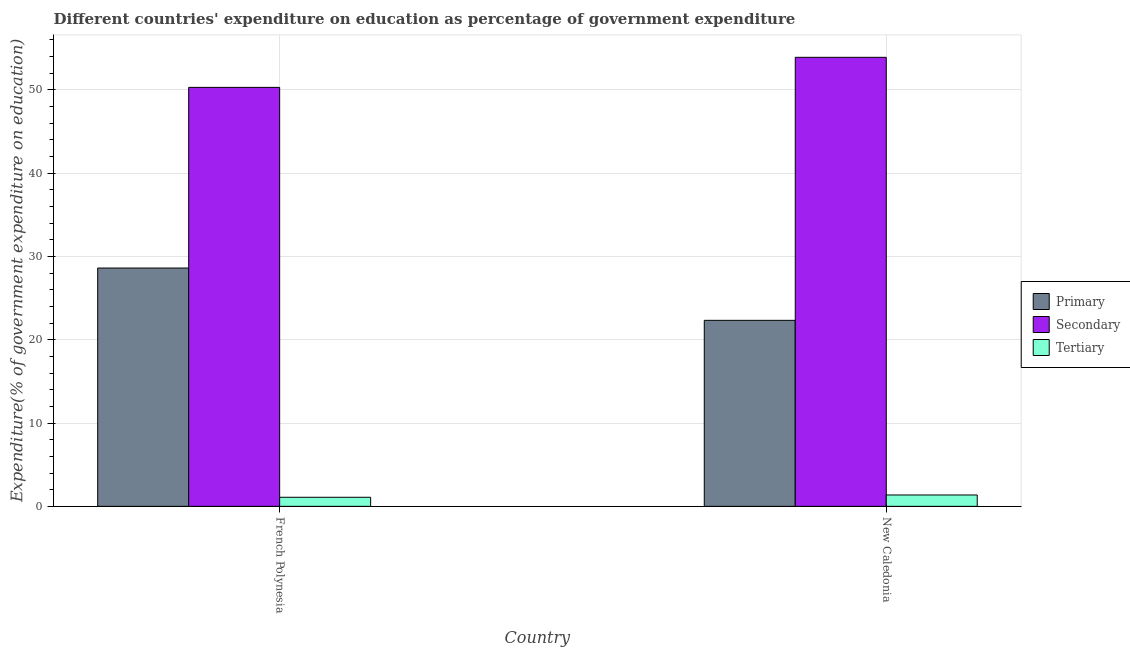How many different coloured bars are there?
Your answer should be very brief. 3. Are the number of bars on each tick of the X-axis equal?
Give a very brief answer. Yes. How many bars are there on the 1st tick from the left?
Your answer should be compact. 3. How many bars are there on the 1st tick from the right?
Your response must be concise. 3. What is the label of the 2nd group of bars from the left?
Provide a short and direct response. New Caledonia. What is the expenditure on tertiary education in French Polynesia?
Offer a terse response. 1.09. Across all countries, what is the maximum expenditure on primary education?
Ensure brevity in your answer.  28.61. Across all countries, what is the minimum expenditure on secondary education?
Give a very brief answer. 50.3. In which country was the expenditure on tertiary education maximum?
Keep it short and to the point. New Caledonia. In which country was the expenditure on secondary education minimum?
Give a very brief answer. French Polynesia. What is the total expenditure on tertiary education in the graph?
Ensure brevity in your answer.  2.45. What is the difference between the expenditure on secondary education in French Polynesia and that in New Caledonia?
Give a very brief answer. -3.61. What is the difference between the expenditure on tertiary education in French Polynesia and the expenditure on secondary education in New Caledonia?
Make the answer very short. -52.82. What is the average expenditure on primary education per country?
Ensure brevity in your answer.  25.47. What is the difference between the expenditure on tertiary education and expenditure on primary education in French Polynesia?
Your response must be concise. -27.52. In how many countries, is the expenditure on tertiary education greater than 40 %?
Ensure brevity in your answer.  0. What is the ratio of the expenditure on secondary education in French Polynesia to that in New Caledonia?
Provide a succinct answer. 0.93. In how many countries, is the expenditure on primary education greater than the average expenditure on primary education taken over all countries?
Provide a succinct answer. 1. What does the 2nd bar from the left in New Caledonia represents?
Offer a very short reply. Secondary. What does the 1st bar from the right in New Caledonia represents?
Ensure brevity in your answer.  Tertiary. Is it the case that in every country, the sum of the expenditure on primary education and expenditure on secondary education is greater than the expenditure on tertiary education?
Give a very brief answer. Yes. How many bars are there?
Provide a succinct answer. 6. Are the values on the major ticks of Y-axis written in scientific E-notation?
Your answer should be very brief. No. How are the legend labels stacked?
Offer a very short reply. Vertical. What is the title of the graph?
Ensure brevity in your answer.  Different countries' expenditure on education as percentage of government expenditure. Does "Ages 15-20" appear as one of the legend labels in the graph?
Your answer should be compact. No. What is the label or title of the X-axis?
Your answer should be compact. Country. What is the label or title of the Y-axis?
Provide a short and direct response. Expenditure(% of government expenditure on education). What is the Expenditure(% of government expenditure on education) in Primary in French Polynesia?
Provide a succinct answer. 28.61. What is the Expenditure(% of government expenditure on education) of Secondary in French Polynesia?
Keep it short and to the point. 50.3. What is the Expenditure(% of government expenditure on education) of Tertiary in French Polynesia?
Offer a very short reply. 1.09. What is the Expenditure(% of government expenditure on education) of Primary in New Caledonia?
Your answer should be very brief. 22.33. What is the Expenditure(% of government expenditure on education) of Secondary in New Caledonia?
Provide a succinct answer. 53.91. What is the Expenditure(% of government expenditure on education) in Tertiary in New Caledonia?
Provide a succinct answer. 1.36. Across all countries, what is the maximum Expenditure(% of government expenditure on education) in Primary?
Provide a short and direct response. 28.61. Across all countries, what is the maximum Expenditure(% of government expenditure on education) in Secondary?
Give a very brief answer. 53.91. Across all countries, what is the maximum Expenditure(% of government expenditure on education) in Tertiary?
Offer a very short reply. 1.36. Across all countries, what is the minimum Expenditure(% of government expenditure on education) of Primary?
Give a very brief answer. 22.33. Across all countries, what is the minimum Expenditure(% of government expenditure on education) in Secondary?
Give a very brief answer. 50.3. Across all countries, what is the minimum Expenditure(% of government expenditure on education) in Tertiary?
Make the answer very short. 1.09. What is the total Expenditure(% of government expenditure on education) of Primary in the graph?
Provide a short and direct response. 50.94. What is the total Expenditure(% of government expenditure on education) of Secondary in the graph?
Give a very brief answer. 104.21. What is the total Expenditure(% of government expenditure on education) in Tertiary in the graph?
Provide a short and direct response. 2.45. What is the difference between the Expenditure(% of government expenditure on education) of Primary in French Polynesia and that in New Caledonia?
Provide a short and direct response. 6.28. What is the difference between the Expenditure(% of government expenditure on education) of Secondary in French Polynesia and that in New Caledonia?
Provide a succinct answer. -3.61. What is the difference between the Expenditure(% of government expenditure on education) in Tertiary in French Polynesia and that in New Caledonia?
Ensure brevity in your answer.  -0.27. What is the difference between the Expenditure(% of government expenditure on education) in Primary in French Polynesia and the Expenditure(% of government expenditure on education) in Secondary in New Caledonia?
Ensure brevity in your answer.  -25.3. What is the difference between the Expenditure(% of government expenditure on education) of Primary in French Polynesia and the Expenditure(% of government expenditure on education) of Tertiary in New Caledonia?
Your answer should be compact. 27.25. What is the difference between the Expenditure(% of government expenditure on education) of Secondary in French Polynesia and the Expenditure(% of government expenditure on education) of Tertiary in New Caledonia?
Provide a succinct answer. 48.94. What is the average Expenditure(% of government expenditure on education) of Primary per country?
Provide a short and direct response. 25.47. What is the average Expenditure(% of government expenditure on education) in Secondary per country?
Offer a very short reply. 52.1. What is the average Expenditure(% of government expenditure on education) in Tertiary per country?
Make the answer very short. 1.23. What is the difference between the Expenditure(% of government expenditure on education) of Primary and Expenditure(% of government expenditure on education) of Secondary in French Polynesia?
Make the answer very short. -21.69. What is the difference between the Expenditure(% of government expenditure on education) of Primary and Expenditure(% of government expenditure on education) of Tertiary in French Polynesia?
Make the answer very short. 27.52. What is the difference between the Expenditure(% of government expenditure on education) in Secondary and Expenditure(% of government expenditure on education) in Tertiary in French Polynesia?
Provide a succinct answer. 49.21. What is the difference between the Expenditure(% of government expenditure on education) of Primary and Expenditure(% of government expenditure on education) of Secondary in New Caledonia?
Make the answer very short. -31.58. What is the difference between the Expenditure(% of government expenditure on education) of Primary and Expenditure(% of government expenditure on education) of Tertiary in New Caledonia?
Keep it short and to the point. 20.97. What is the difference between the Expenditure(% of government expenditure on education) of Secondary and Expenditure(% of government expenditure on education) of Tertiary in New Caledonia?
Give a very brief answer. 52.54. What is the ratio of the Expenditure(% of government expenditure on education) in Primary in French Polynesia to that in New Caledonia?
Offer a terse response. 1.28. What is the ratio of the Expenditure(% of government expenditure on education) in Secondary in French Polynesia to that in New Caledonia?
Offer a very short reply. 0.93. What is the ratio of the Expenditure(% of government expenditure on education) in Tertiary in French Polynesia to that in New Caledonia?
Your answer should be very brief. 0.8. What is the difference between the highest and the second highest Expenditure(% of government expenditure on education) in Primary?
Your answer should be very brief. 6.28. What is the difference between the highest and the second highest Expenditure(% of government expenditure on education) in Secondary?
Offer a terse response. 3.61. What is the difference between the highest and the second highest Expenditure(% of government expenditure on education) of Tertiary?
Ensure brevity in your answer.  0.27. What is the difference between the highest and the lowest Expenditure(% of government expenditure on education) of Primary?
Offer a very short reply. 6.28. What is the difference between the highest and the lowest Expenditure(% of government expenditure on education) of Secondary?
Your answer should be very brief. 3.61. What is the difference between the highest and the lowest Expenditure(% of government expenditure on education) of Tertiary?
Offer a very short reply. 0.27. 